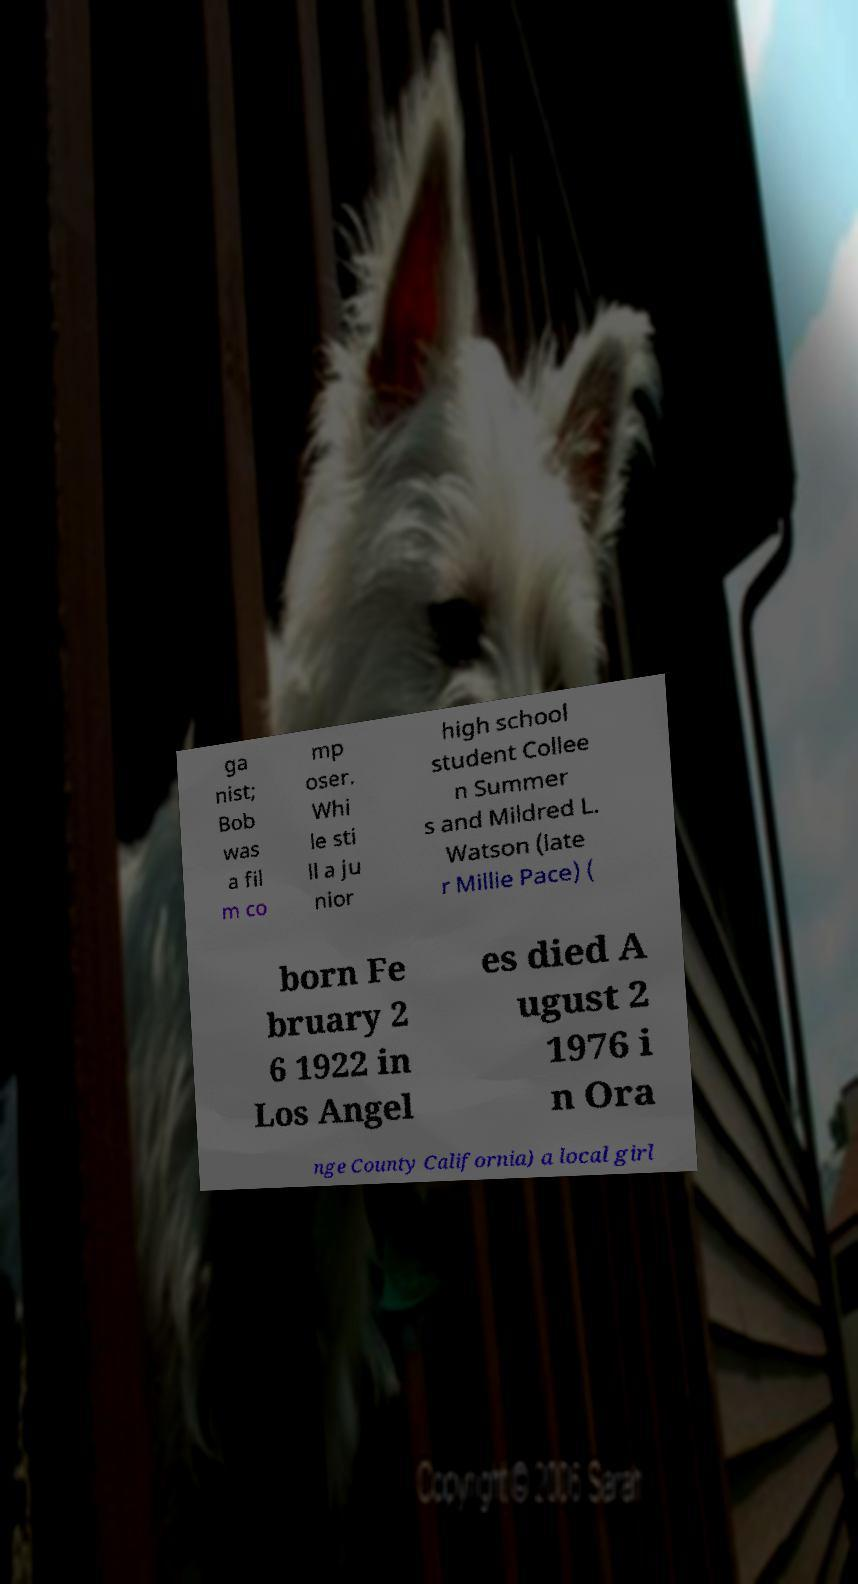Could you assist in decoding the text presented in this image and type it out clearly? ga nist; Bob was a fil m co mp oser. Whi le sti ll a ju nior high school student Collee n Summer s and Mildred L. Watson (late r Millie Pace) ( born Fe bruary 2 6 1922 in Los Angel es died A ugust 2 1976 i n Ora nge County California) a local girl 